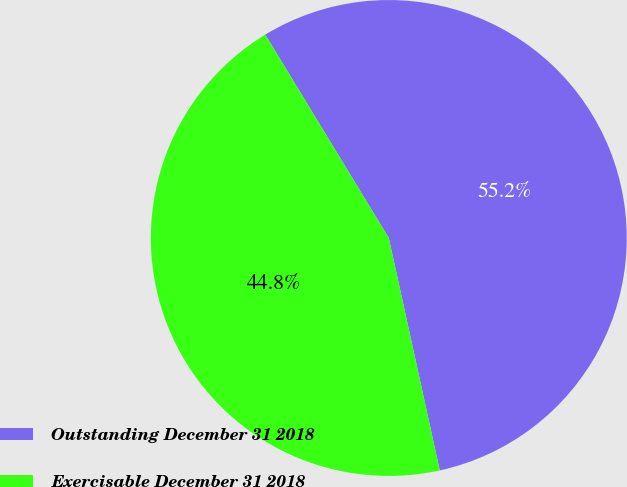<chart> <loc_0><loc_0><loc_500><loc_500><pie_chart><fcel>Outstanding December 31 2018<fcel>Exercisable December 31 2018<nl><fcel>55.25%<fcel>44.75%<nl></chart> 